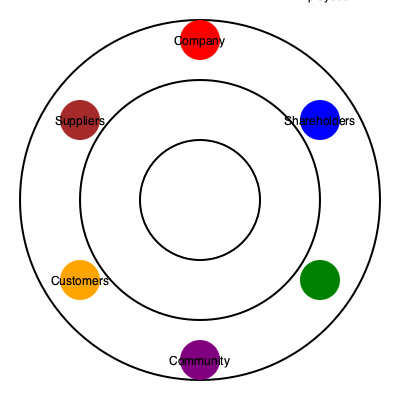In the given network diagram of stakeholders affected by a corporate decision, which stakeholder group is positioned furthest from the company in terms of spatial relationship, and what might this imply about their level of impact or influence in the decision-making process? To answer this question, we need to analyze the spatial relationships in the network diagram:

1. The diagram consists of concentric circles with the company at the center.

2. The stakeholders are positioned at various distances from the center:
   - Company: At the center (innermost circle)
   - Shareholders: On the second circle from the center
   - Employees: On the second circle from the center
   - Suppliers: On the second circle from the center
   - Customers: On the second circle from the center
   - Community: On the outermost circle

3. The community stakeholder group is positioned on the outermost circle, making it the furthest from the company in terms of spatial relationship.

4. In network diagrams, distance often represents the degree of direct influence or impact. Stakeholders closer to the center are typically considered to have more direct influence or be more immediately affected by decisions.

5. The community's position on the outer circle might imply that they have less direct influence on the company's decision-making process or are less immediately impacted by the company's decisions compared to other stakeholders.

6. However, it's important to note that this spatial relationship doesn't necessarily mean the community is unimportant. It might suggest that the impact on the community is more indirect or long-term, or that extra effort may be needed to consider and incorporate community perspectives in ethical decision-making.
Answer: Community; potentially less direct influence or immediate impact 